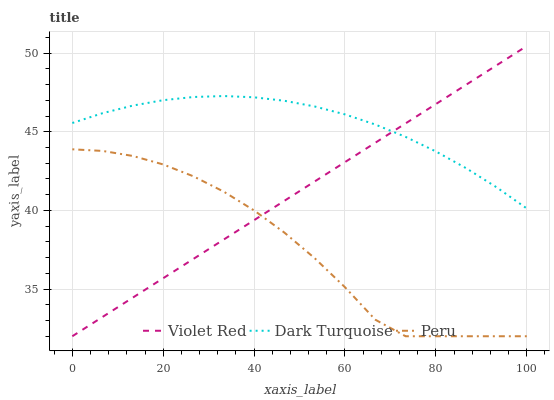Does Peru have the minimum area under the curve?
Answer yes or no. Yes. Does Dark Turquoise have the maximum area under the curve?
Answer yes or no. Yes. Does Violet Red have the minimum area under the curve?
Answer yes or no. No. Does Violet Red have the maximum area under the curve?
Answer yes or no. No. Is Violet Red the smoothest?
Answer yes or no. Yes. Is Peru the roughest?
Answer yes or no. Yes. Is Peru the smoothest?
Answer yes or no. No. Is Violet Red the roughest?
Answer yes or no. No. Does Violet Red have the highest value?
Answer yes or no. Yes. Does Peru have the highest value?
Answer yes or no. No. Is Peru less than Dark Turquoise?
Answer yes or no. Yes. Is Dark Turquoise greater than Peru?
Answer yes or no. Yes. Does Peru intersect Dark Turquoise?
Answer yes or no. No. 